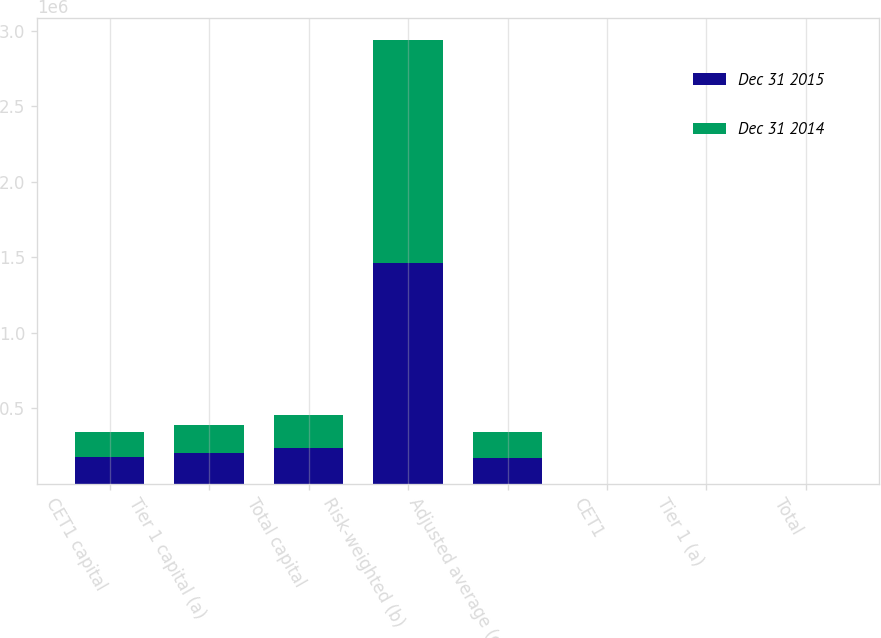Convert chart. <chart><loc_0><loc_0><loc_500><loc_500><stacked_bar_chart><ecel><fcel>CET1 capital<fcel>Tier 1 capital (a)<fcel>Total capital<fcel>Risk-weighted (b)<fcel>Adjusted average (c)<fcel>CET1<fcel>Tier 1 (a)<fcel>Total<nl><fcel>Dec 31 2015<fcel>175398<fcel>200482<fcel>234413<fcel>1.46526e+06<fcel>169912<fcel>12<fcel>13.7<fcel>16<nl><fcel>Dec 31 2014<fcel>164426<fcel>186263<fcel>221117<fcel>1.4726e+06<fcel>169912<fcel>11.2<fcel>12.6<fcel>15<nl></chart> 